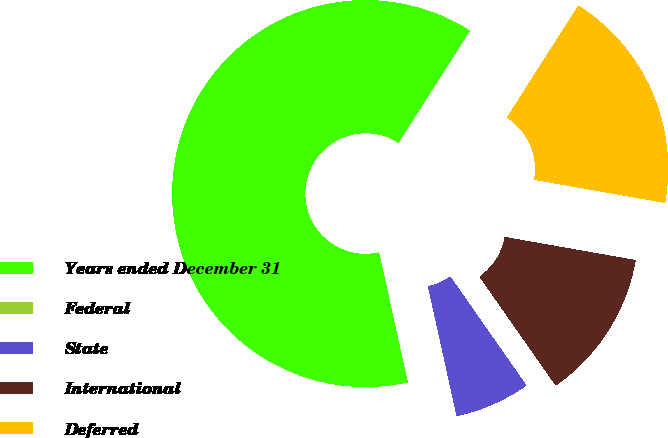<chart> <loc_0><loc_0><loc_500><loc_500><pie_chart><fcel>Years ended December 31<fcel>Federal<fcel>State<fcel>International<fcel>Deferred<nl><fcel>62.49%<fcel>0.0%<fcel>6.25%<fcel>12.5%<fcel>18.75%<nl></chart> 